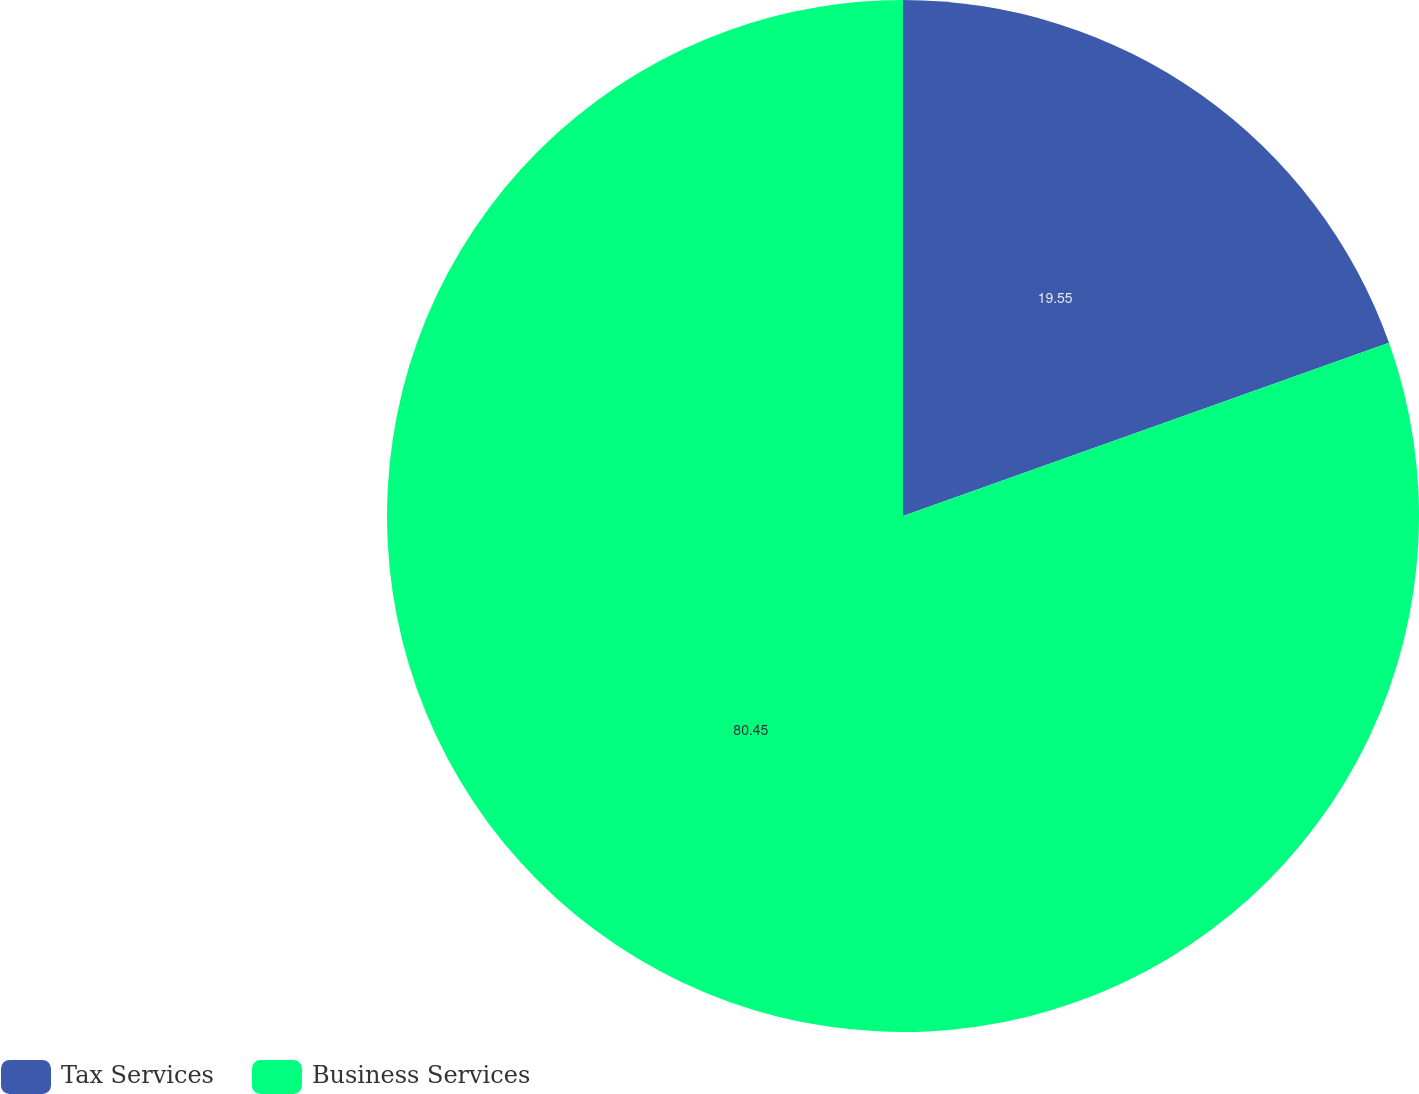<chart> <loc_0><loc_0><loc_500><loc_500><pie_chart><fcel>Tax Services<fcel>Business Services<nl><fcel>19.55%<fcel>80.45%<nl></chart> 